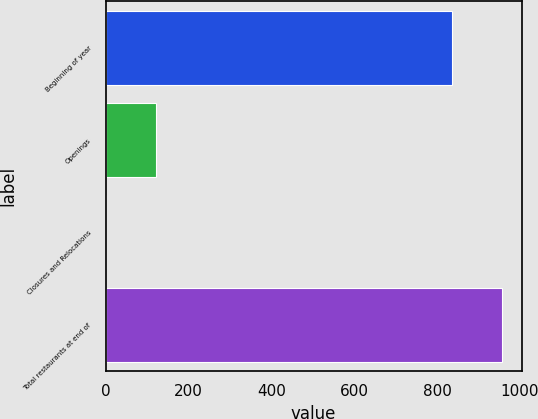Convert chart. <chart><loc_0><loc_0><loc_500><loc_500><bar_chart><fcel>Beginning of year<fcel>Openings<fcel>Closures and Relocations<fcel>Total restaurants at end of<nl><fcel>837<fcel>121<fcel>2<fcel>956<nl></chart> 